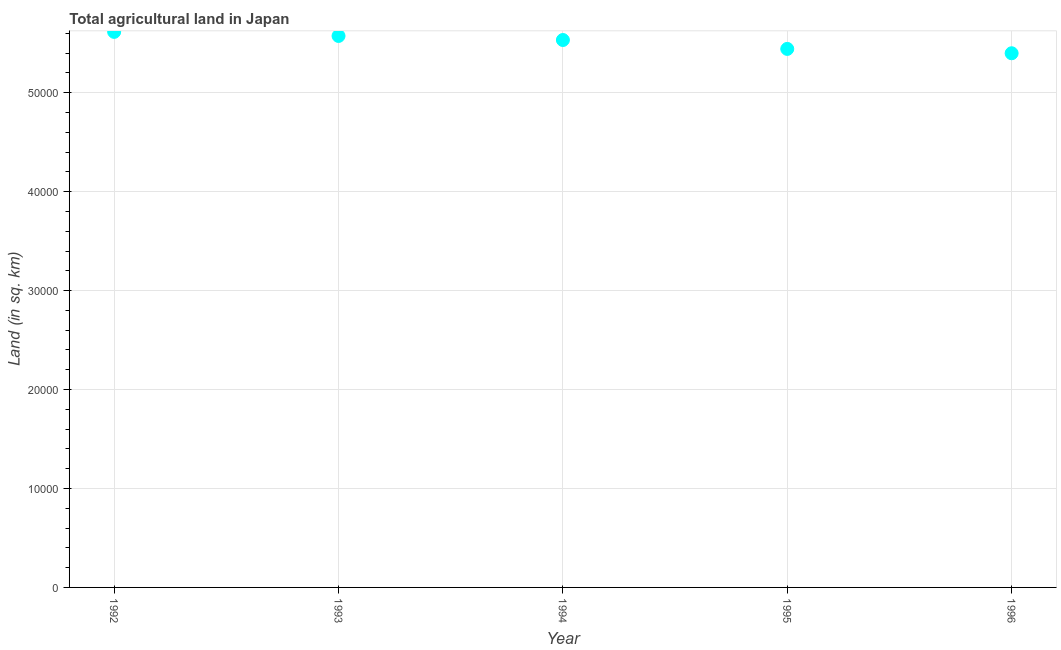What is the agricultural land in 1994?
Provide a succinct answer. 5.53e+04. Across all years, what is the maximum agricultural land?
Give a very brief answer. 5.62e+04. Across all years, what is the minimum agricultural land?
Give a very brief answer. 5.40e+04. In which year was the agricultural land maximum?
Give a very brief answer. 1992. What is the sum of the agricultural land?
Ensure brevity in your answer.  2.76e+05. What is the difference between the agricultural land in 1993 and 1995?
Make the answer very short. 1310. What is the average agricultural land per year?
Offer a very short reply. 5.51e+04. What is the median agricultural land?
Your response must be concise. 5.53e+04. Do a majority of the years between 1995 and 1992 (inclusive) have agricultural land greater than 8000 sq. km?
Your answer should be compact. Yes. What is the ratio of the agricultural land in 1994 to that in 1995?
Your answer should be very brief. 1.02. Is the agricultural land in 1993 less than that in 1995?
Provide a succinct answer. No. What is the difference between the highest and the second highest agricultural land?
Provide a short and direct response. 410. What is the difference between the highest and the lowest agricultural land?
Make the answer very short. 2160. How many dotlines are there?
Make the answer very short. 1. How many years are there in the graph?
Provide a short and direct response. 5. Does the graph contain grids?
Your answer should be very brief. Yes. What is the title of the graph?
Your response must be concise. Total agricultural land in Japan. What is the label or title of the Y-axis?
Offer a very short reply. Land (in sq. km). What is the Land (in sq. km) in 1992?
Keep it short and to the point. 5.62e+04. What is the Land (in sq. km) in 1993?
Make the answer very short. 5.57e+04. What is the Land (in sq. km) in 1994?
Keep it short and to the point. 5.53e+04. What is the Land (in sq. km) in 1995?
Your answer should be very brief. 5.44e+04. What is the Land (in sq. km) in 1996?
Make the answer very short. 5.40e+04. What is the difference between the Land (in sq. km) in 1992 and 1993?
Keep it short and to the point. 410. What is the difference between the Land (in sq. km) in 1992 and 1994?
Provide a succinct answer. 820. What is the difference between the Land (in sq. km) in 1992 and 1995?
Provide a succinct answer. 1720. What is the difference between the Land (in sq. km) in 1992 and 1996?
Your response must be concise. 2160. What is the difference between the Land (in sq. km) in 1993 and 1994?
Make the answer very short. 410. What is the difference between the Land (in sq. km) in 1993 and 1995?
Your answer should be very brief. 1310. What is the difference between the Land (in sq. km) in 1993 and 1996?
Provide a succinct answer. 1750. What is the difference between the Land (in sq. km) in 1994 and 1995?
Give a very brief answer. 900. What is the difference between the Land (in sq. km) in 1994 and 1996?
Offer a very short reply. 1340. What is the difference between the Land (in sq. km) in 1995 and 1996?
Offer a very short reply. 440. What is the ratio of the Land (in sq. km) in 1992 to that in 1993?
Provide a short and direct response. 1.01. What is the ratio of the Land (in sq. km) in 1992 to that in 1994?
Give a very brief answer. 1.01. What is the ratio of the Land (in sq. km) in 1992 to that in 1995?
Your response must be concise. 1.03. What is the ratio of the Land (in sq. km) in 1993 to that in 1995?
Your answer should be compact. 1.02. What is the ratio of the Land (in sq. km) in 1993 to that in 1996?
Your answer should be very brief. 1.03. What is the ratio of the Land (in sq. km) in 1994 to that in 1995?
Your answer should be very brief. 1.02. What is the ratio of the Land (in sq. km) in 1994 to that in 1996?
Provide a succinct answer. 1.02. What is the ratio of the Land (in sq. km) in 1995 to that in 1996?
Your response must be concise. 1.01. 